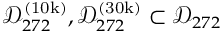<formula> <loc_0><loc_0><loc_500><loc_500>\mathcal { D } _ { 2 7 2 } ^ { ( 1 0 k ) } , \mathcal { D } _ { 2 7 2 } ^ { ( 3 0 k ) } \subset \mathcal { D } _ { 2 7 2 }</formula> 